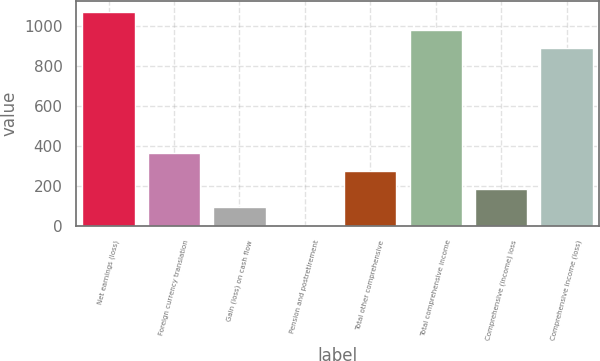<chart> <loc_0><loc_0><loc_500><loc_500><bar_chart><fcel>Net earnings (loss)<fcel>Foreign currency translation<fcel>Gain (loss) on cash flow<fcel>Pension and postretirement<fcel>Total other comprehensive<fcel>Total comprehensive income<fcel>Comprehensive (income) loss<fcel>Comprehensive income (loss)<nl><fcel>1070.4<fcel>364.8<fcel>94.2<fcel>4<fcel>274.6<fcel>980.2<fcel>184.4<fcel>890<nl></chart> 